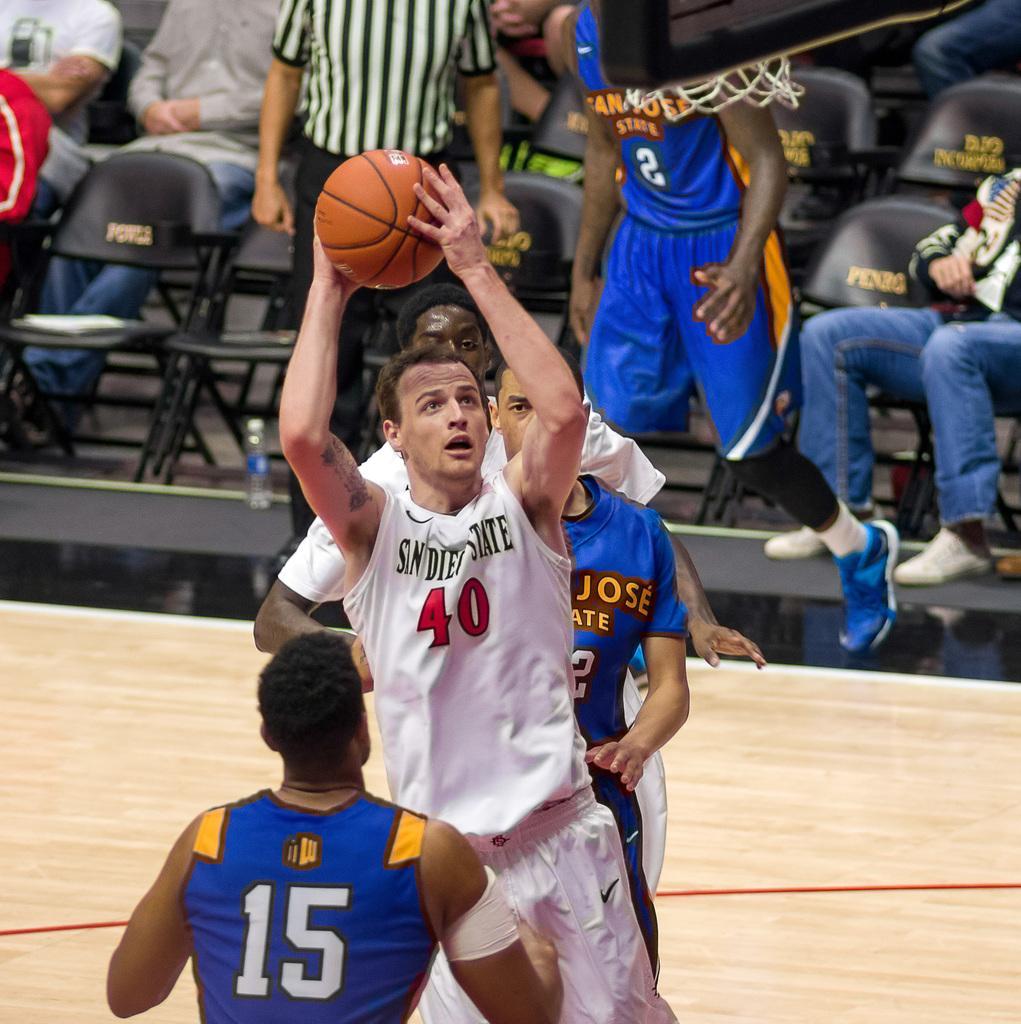Could you give a brief overview of what you see in this image? In this picture we can see few people and one person is holding a ball and in the background we can see a group of people, ground, chairs, bottle and some objects. 